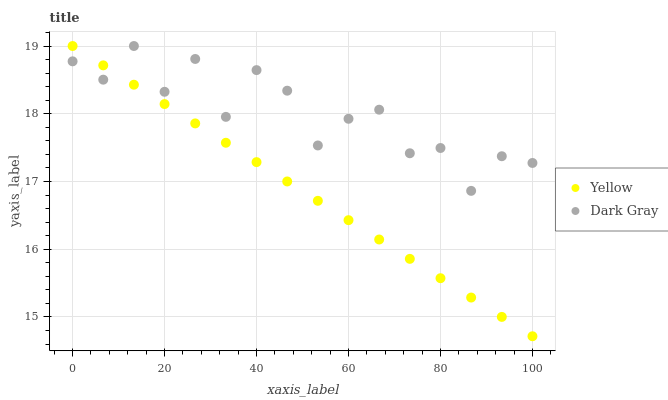Does Yellow have the minimum area under the curve?
Answer yes or no. Yes. Does Dark Gray have the maximum area under the curve?
Answer yes or no. Yes. Does Yellow have the maximum area under the curve?
Answer yes or no. No. Is Yellow the smoothest?
Answer yes or no. Yes. Is Dark Gray the roughest?
Answer yes or no. Yes. Is Yellow the roughest?
Answer yes or no. No. Does Yellow have the lowest value?
Answer yes or no. Yes. Does Yellow have the highest value?
Answer yes or no. Yes. Does Yellow intersect Dark Gray?
Answer yes or no. Yes. Is Yellow less than Dark Gray?
Answer yes or no. No. Is Yellow greater than Dark Gray?
Answer yes or no. No. 